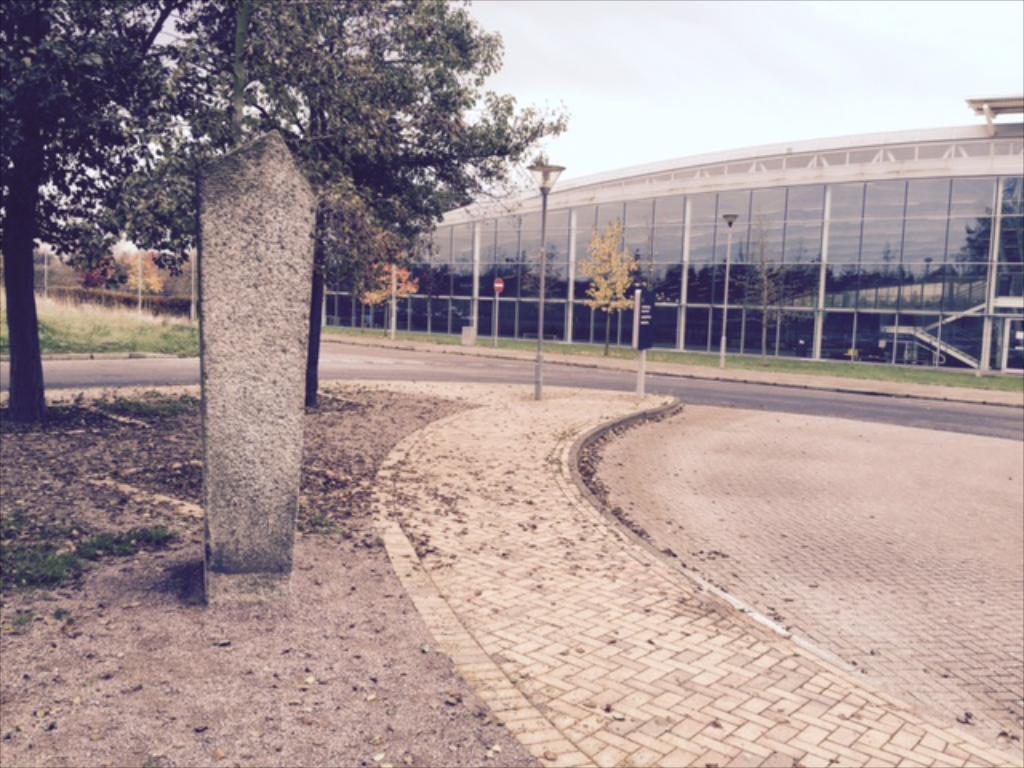Could you give a brief overview of what you see in this image? In this image there is a floor, in the background there is road, building, poles and trees. 